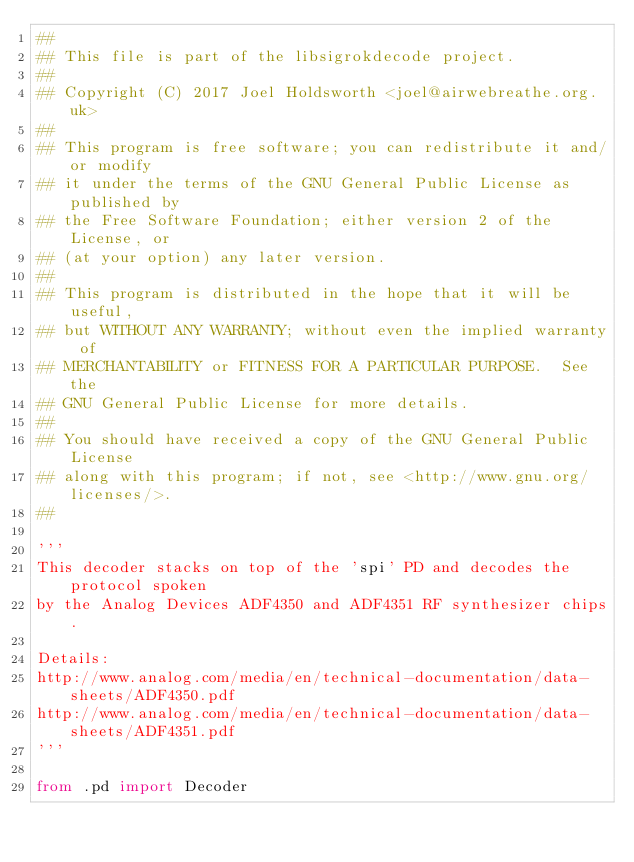Convert code to text. <code><loc_0><loc_0><loc_500><loc_500><_Python_>##
## This file is part of the libsigrokdecode project.
##
## Copyright (C) 2017 Joel Holdsworth <joel@airwebreathe.org.uk>
##
## This program is free software; you can redistribute it and/or modify
## it under the terms of the GNU General Public License as published by
## the Free Software Foundation; either version 2 of the License, or
## (at your option) any later version.
##
## This program is distributed in the hope that it will be useful,
## but WITHOUT ANY WARRANTY; without even the implied warranty of
## MERCHANTABILITY or FITNESS FOR A PARTICULAR PURPOSE.  See the
## GNU General Public License for more details.
##
## You should have received a copy of the GNU General Public License
## along with this program; if not, see <http://www.gnu.org/licenses/>.
##

'''
This decoder stacks on top of the 'spi' PD and decodes the protocol spoken
by the Analog Devices ADF4350 and ADF4351 RF synthesizer chips.

Details:
http://www.analog.com/media/en/technical-documentation/data-sheets/ADF4350.pdf
http://www.analog.com/media/en/technical-documentation/data-sheets/ADF4351.pdf
'''

from .pd import Decoder
</code> 